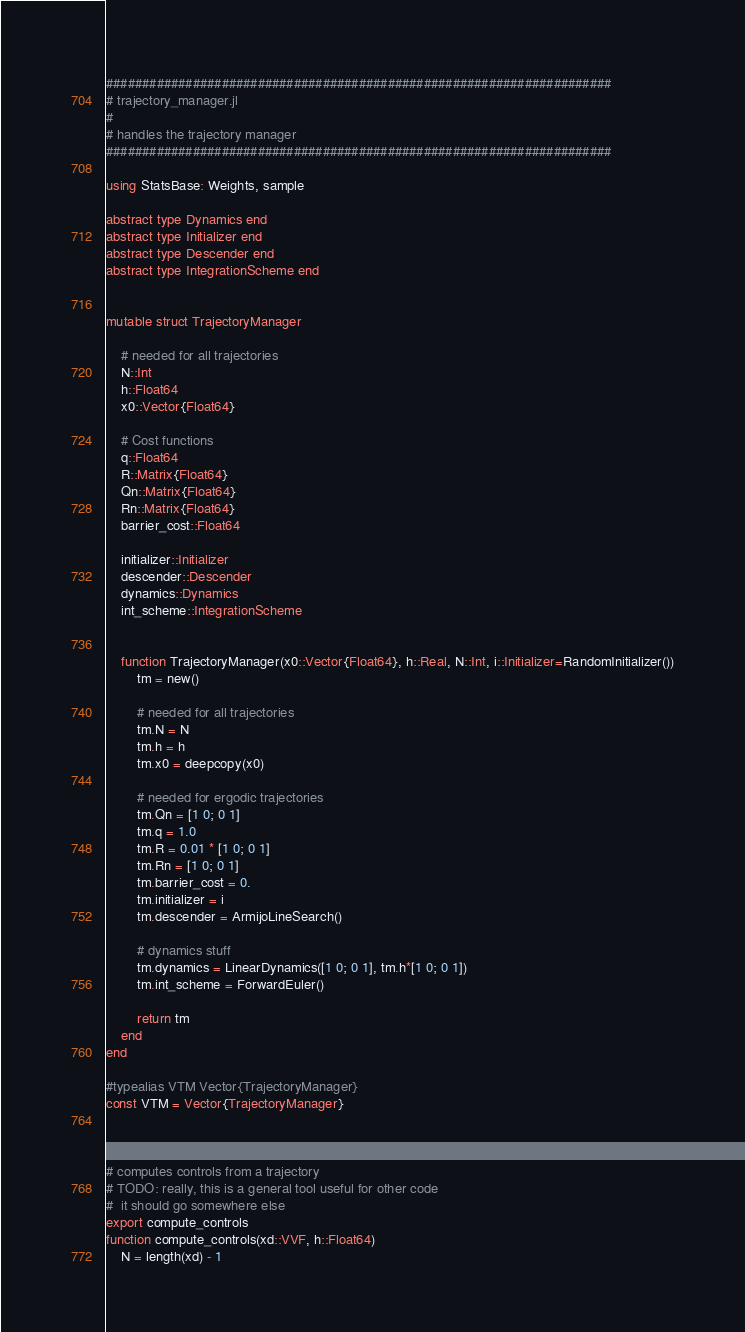Convert code to text. <code><loc_0><loc_0><loc_500><loc_500><_Julia_>######################################################################
# trajectory_manager.jl
#
# handles the trajectory manager
######################################################################

using StatsBase: Weights, sample

abstract type Dynamics end
abstract type Initializer end
abstract type Descender end
abstract type IntegrationScheme end


mutable struct TrajectoryManager

	# needed for all trajectories
	N::Int
	h::Float64
	x0::Vector{Float64}

	# Cost functions
	q::Float64
	R::Matrix{Float64}
	Qn::Matrix{Float64}
	Rn::Matrix{Float64}
	barrier_cost::Float64

	initializer::Initializer
	descender::Descender
	dynamics::Dynamics
	int_scheme::IntegrationScheme


	function TrajectoryManager(x0::Vector{Float64}, h::Real, N::Int, i::Initializer=RandomInitializer())
		tm = new()

		# needed for all trajectories
		tm.N = N
		tm.h = h
		tm.x0 = deepcopy(x0)

		# needed for ergodic trajectories
		tm.Qn = [1 0; 0 1]
		tm.q = 1.0
		tm.R = 0.01 * [1 0; 0 1]
		tm.Rn = [1 0; 0 1]
		tm.barrier_cost = 0.
		tm.initializer = i
		tm.descender = ArmijoLineSearch()

		# dynamics stuff
		tm.dynamics = LinearDynamics([1 0; 0 1], tm.h*[1 0; 0 1])
		tm.int_scheme = ForwardEuler()

		return tm
	end
end

#typealias VTM Vector{TrajectoryManager}
const VTM = Vector{TrajectoryManager}



# computes controls from a trajectory
# TODO: really, this is a general tool useful for other code
#  it should go somewhere else
export compute_controls
function compute_controls(xd::VVF, h::Float64)
	N = length(xd) - 1</code> 